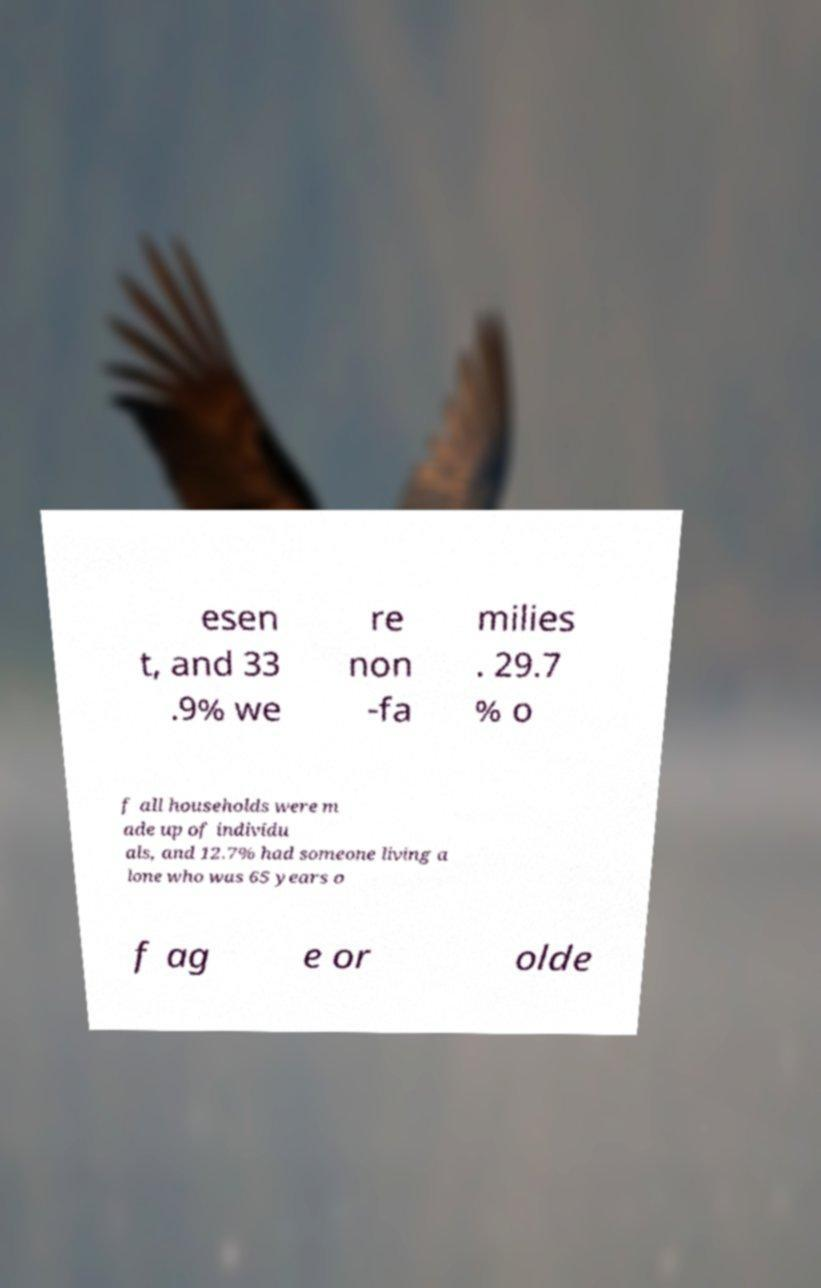Please identify and transcribe the text found in this image. esen t, and 33 .9% we re non -fa milies . 29.7 % o f all households were m ade up of individu als, and 12.7% had someone living a lone who was 65 years o f ag e or olde 